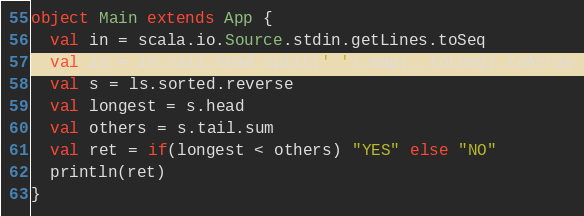Convert code to text. <code><loc_0><loc_0><loc_500><loc_500><_Scala_>object Main extends App {
  val in = scala.io.Source.stdin.getLines.toSeq
  val ls = in.tail.head.split(' ').map(_.toLong).toArray
  val s = ls.sorted.reverse
  val longest = s.head
  val others = s.tail.sum
  val ret = if(longest < others) "YES" else "NO"
  println(ret)
}
</code> 